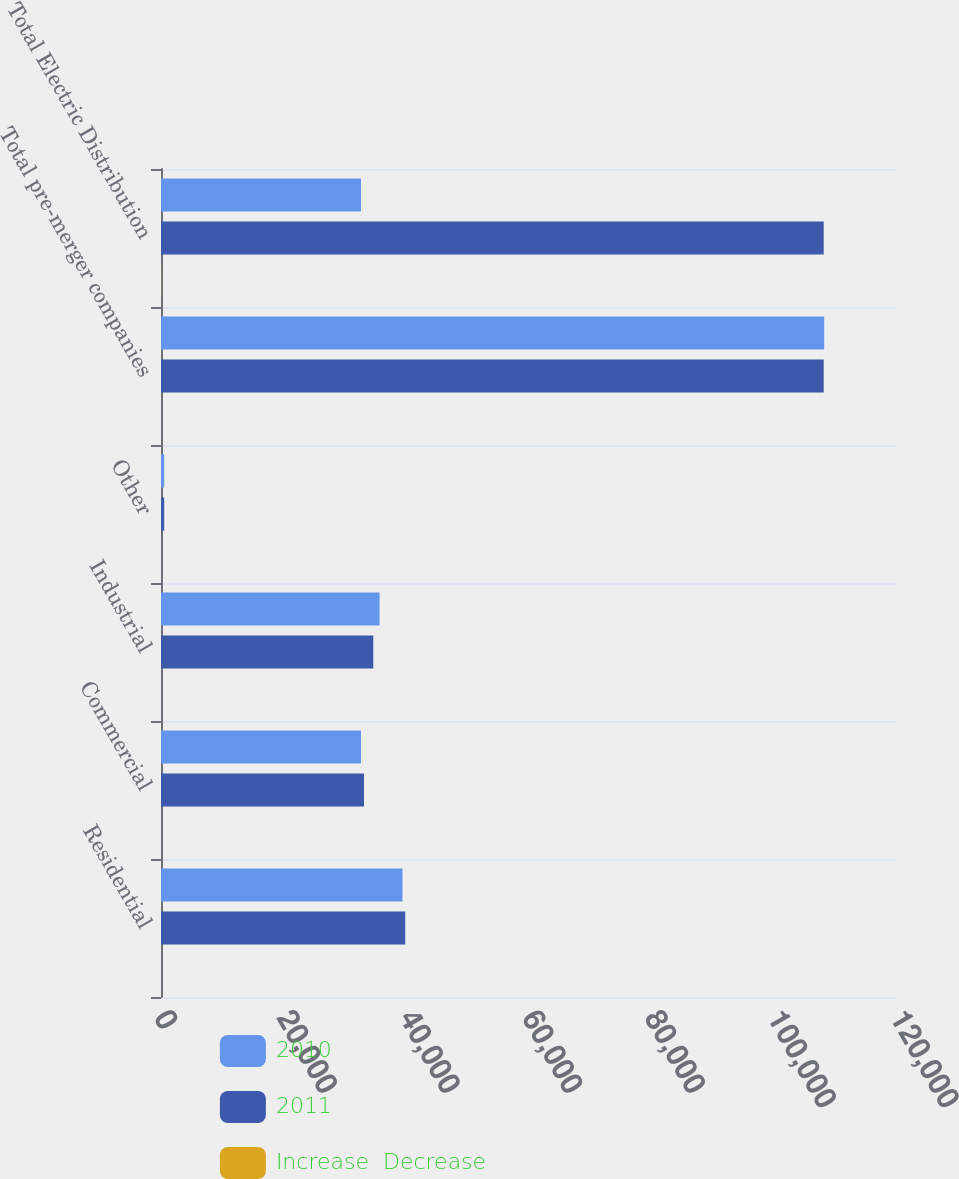Convert chart. <chart><loc_0><loc_0><loc_500><loc_500><stacked_bar_chart><ecel><fcel>Residential<fcel>Commercial<fcel>Industrial<fcel>Other<fcel>Total pre-merger companies<fcel>Total Electric Distribution<nl><fcel>2010<fcel>39369<fcel>32610<fcel>35637<fcel>513<fcel>108129<fcel>32610<nl><fcel>2011<fcel>39820<fcel>33096<fcel>34613<fcel>522<fcel>108051<fcel>108051<nl><fcel>Increase  Decrease<fcel>1.1<fcel>1.5<fcel>3<fcel>1.7<fcel>0.1<fcel>31<nl></chart> 